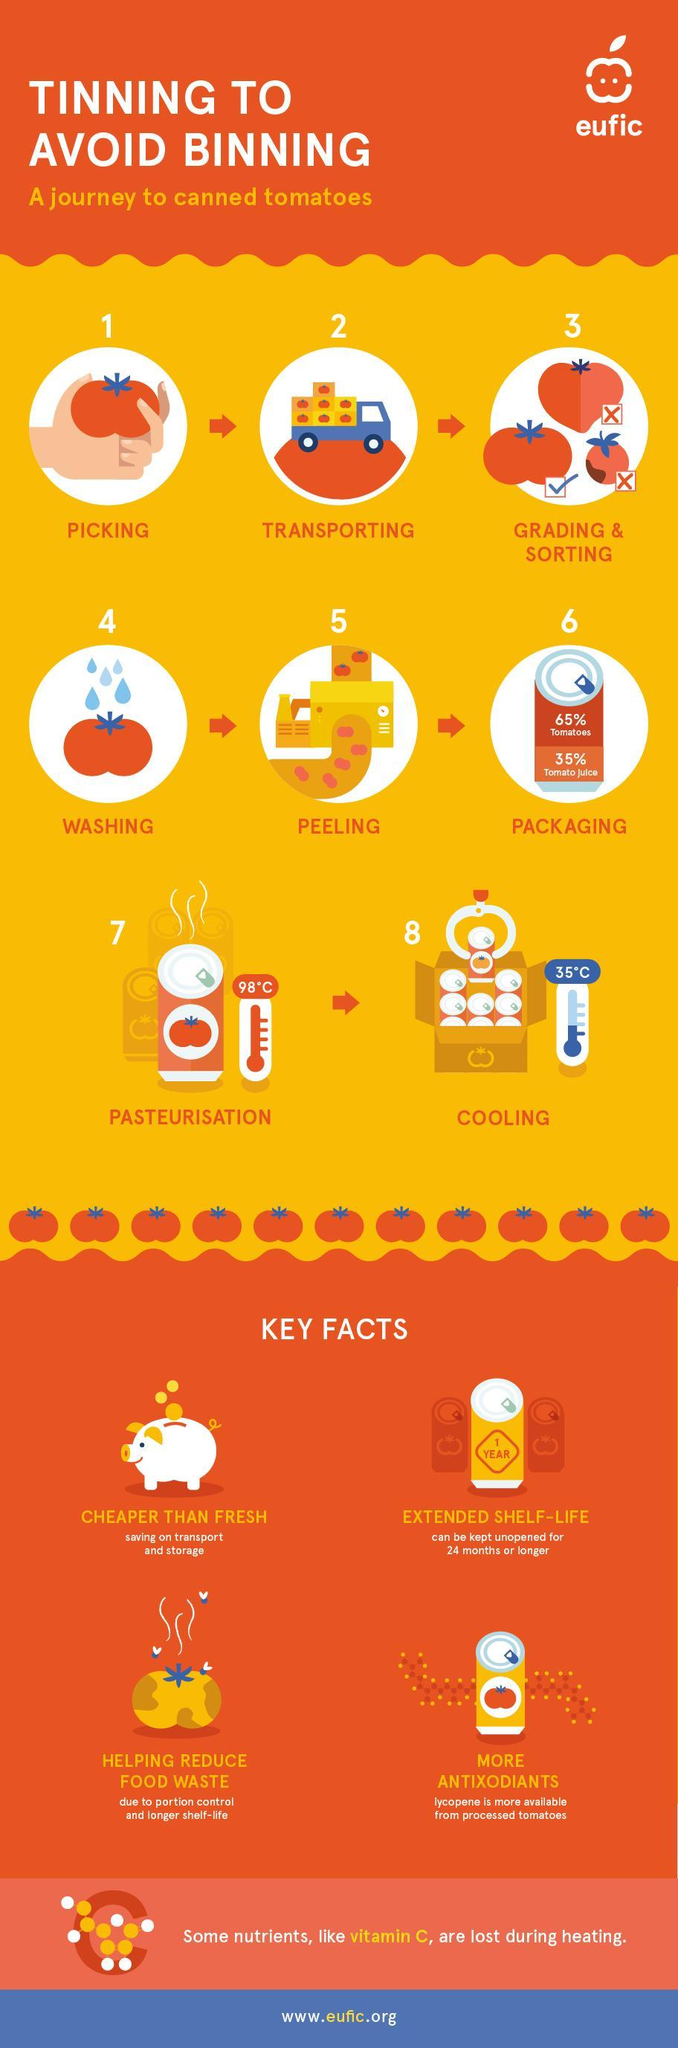Which is the step 6 while tinning and canning tomatoes, washing, peeling, or packaging?
Answer the question with a short phrase. packaging What is the temperature in which the tomatoes have to be cooled, 98, 35, or 100 in degree Celsius? 35 What is the shelf life of tomatoes when the are canned, 1 year, 2 years, or 2 years or more? 2 years or more What is the percentage of tomatoes written on the can? 65% What is the percentage of tomato juice written on the can? 35% Which is the step 8 while canning tomatoes pasteurization, cooling, or packaging? cooling What is the temperature in which the tomatoes have to be pasteurized, 98, 35, or 100 in degree Celsius? 98 